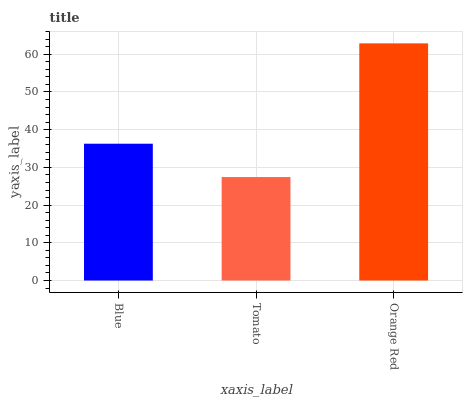Is Orange Red the minimum?
Answer yes or no. No. Is Tomato the maximum?
Answer yes or no. No. Is Orange Red greater than Tomato?
Answer yes or no. Yes. Is Tomato less than Orange Red?
Answer yes or no. Yes. Is Tomato greater than Orange Red?
Answer yes or no. No. Is Orange Red less than Tomato?
Answer yes or no. No. Is Blue the high median?
Answer yes or no. Yes. Is Blue the low median?
Answer yes or no. Yes. Is Tomato the high median?
Answer yes or no. No. Is Orange Red the low median?
Answer yes or no. No. 